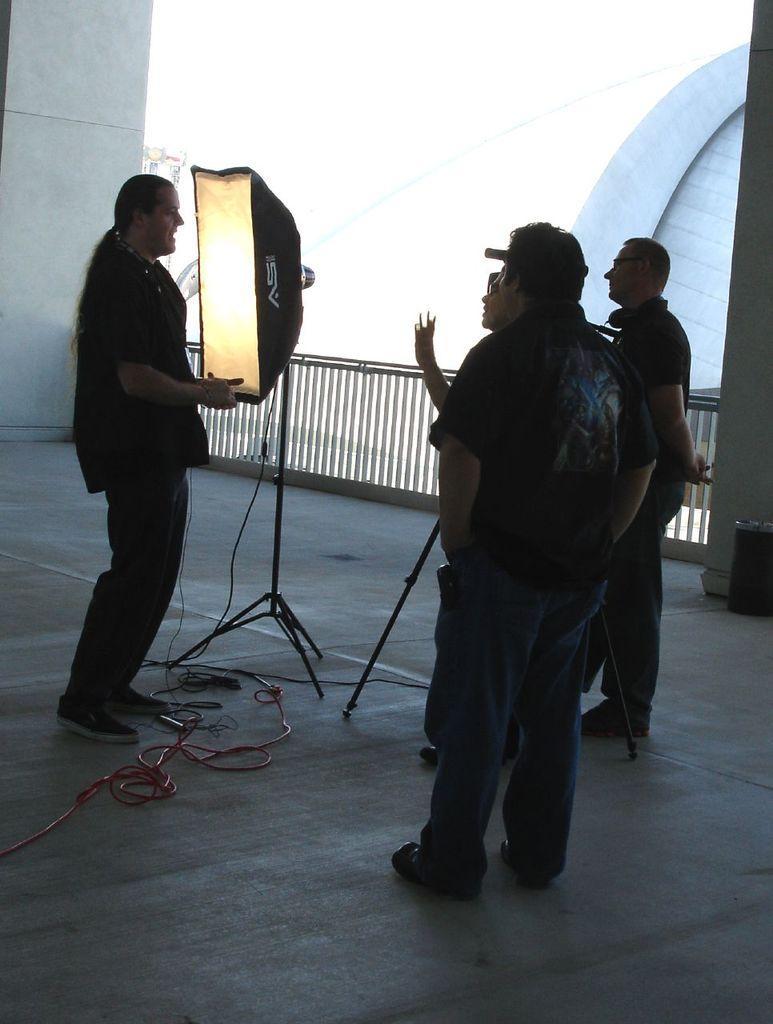How would you summarize this image in a sentence or two? In this image we can see a group of people standing on the ground. In the center of the image we can see a soft box placed on a stand with some cables. In the background, we can see a barricade, trash bin placed on the ground, pillars, buildings and the sky. 